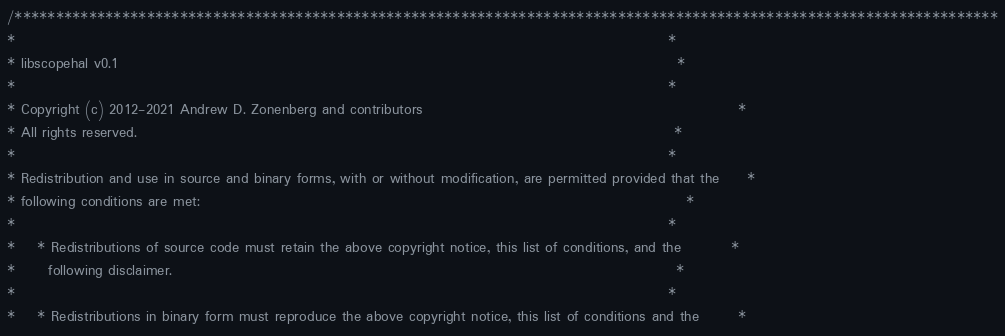Convert code to text. <code><loc_0><loc_0><loc_500><loc_500><_C++_>/***********************************************************************************************************************
*                                                                                                                      *
* libscopehal v0.1                                                                                                     *
*                                                                                                                      *
* Copyright (c) 2012-2021 Andrew D. Zonenberg and contributors                                                         *
* All rights reserved.                                                                                                 *
*                                                                                                                      *
* Redistribution and use in source and binary forms, with or without modification, are permitted provided that the     *
* following conditions are met:                                                                                        *
*                                                                                                                      *
*    * Redistributions of source code must retain the above copyright notice, this list of conditions, and the         *
*      following disclaimer.                                                                                           *
*                                                                                                                      *
*    * Redistributions in binary form must reproduce the above copyright notice, this list of conditions and the       *</code> 